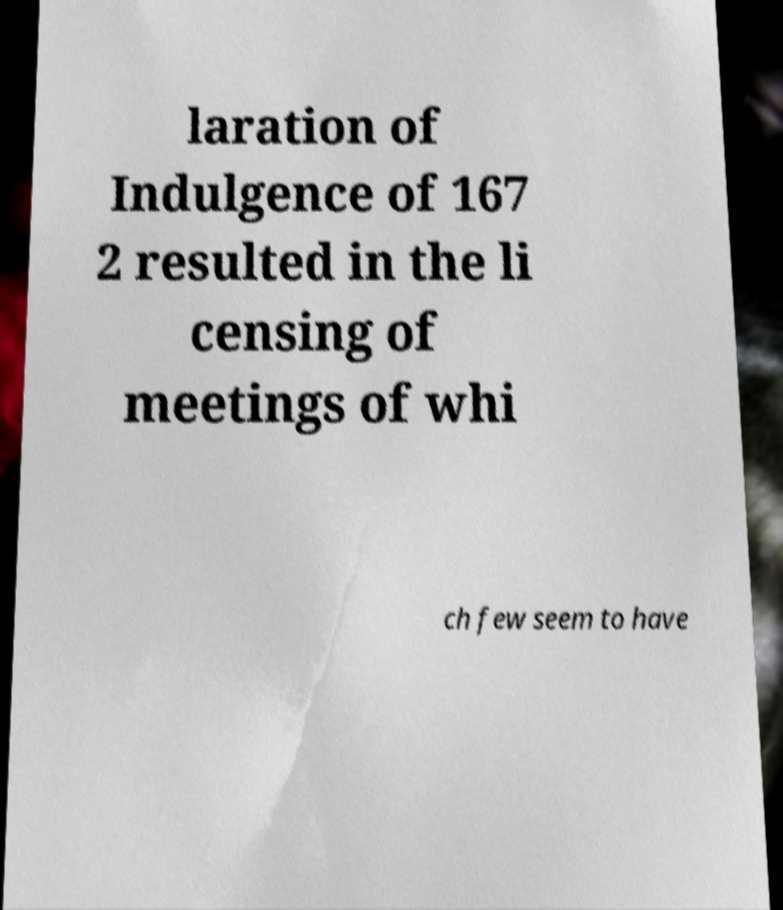Please read and relay the text visible in this image. What does it say? laration of Indulgence of 167 2 resulted in the li censing of meetings of whi ch few seem to have 